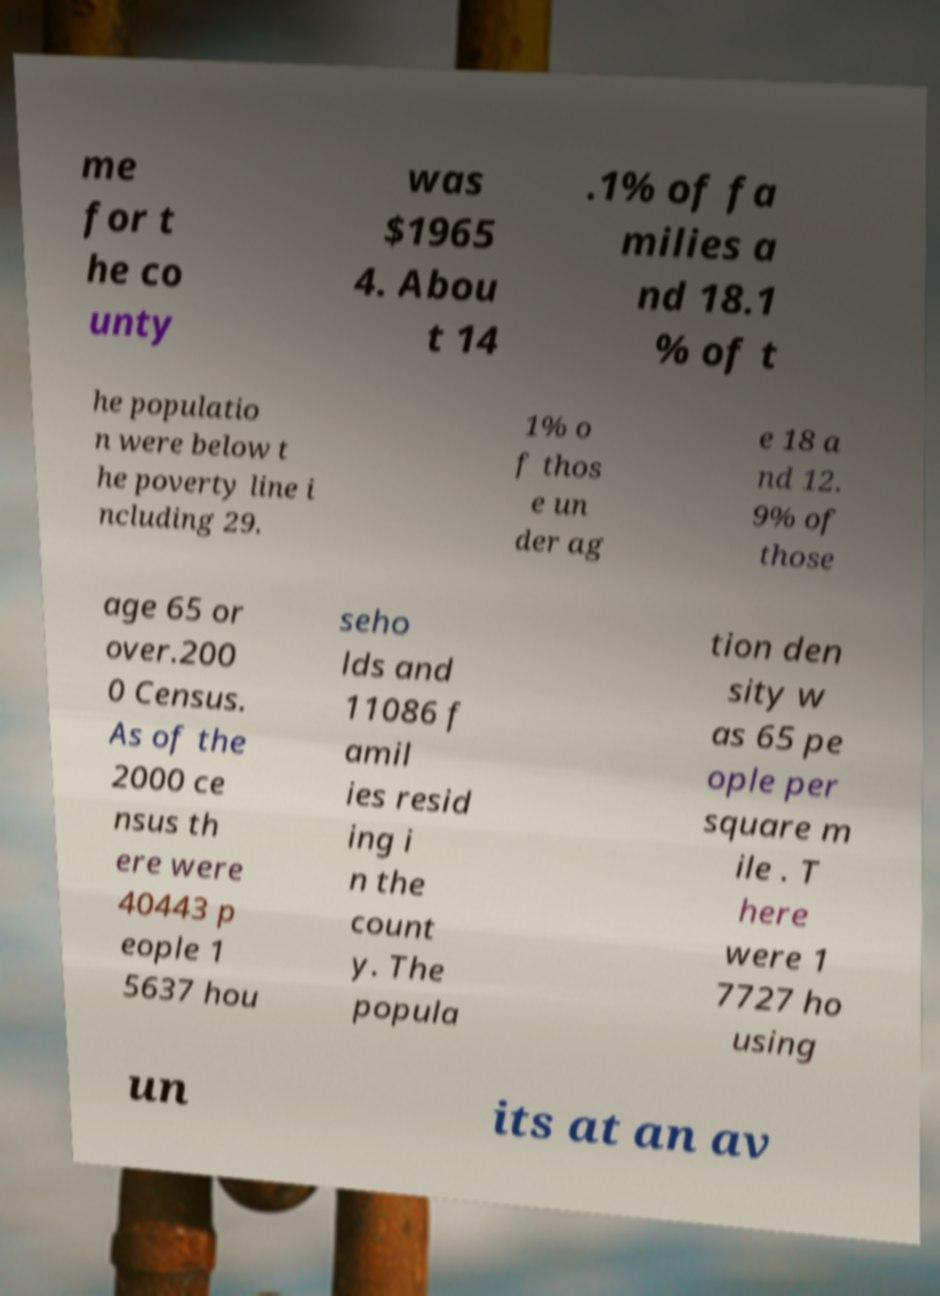Can you read and provide the text displayed in the image?This photo seems to have some interesting text. Can you extract and type it out for me? me for t he co unty was $1965 4. Abou t 14 .1% of fa milies a nd 18.1 % of t he populatio n were below t he poverty line i ncluding 29. 1% o f thos e un der ag e 18 a nd 12. 9% of those age 65 or over.200 0 Census. As of the 2000 ce nsus th ere were 40443 p eople 1 5637 hou seho lds and 11086 f amil ies resid ing i n the count y. The popula tion den sity w as 65 pe ople per square m ile . T here were 1 7727 ho using un its at an av 